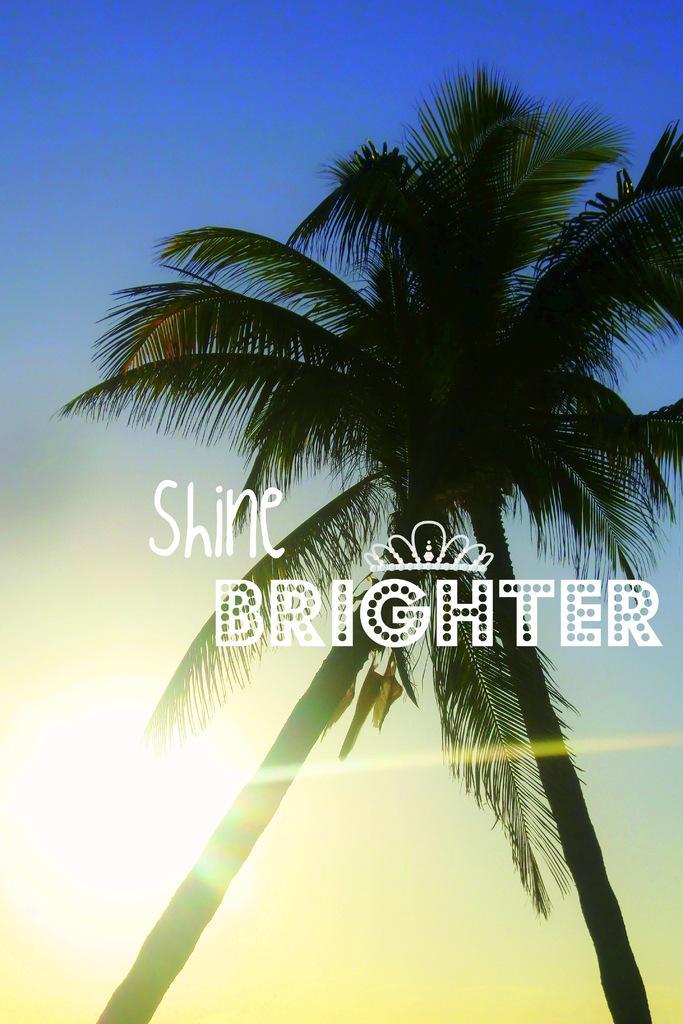Describe this image in one or two sentences. In this we can see two coconut trees. In the background there is sky. Also something is written on the image. 